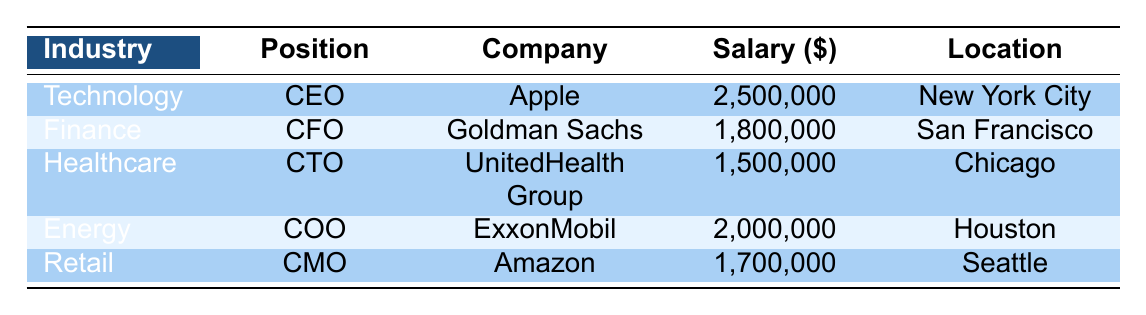What is the highest salary listed in the table? The table provides salaries for various positions across different companies. Scanning through the salary column, the highest figure is 2,500,000 associated with the position of CEO at Apple.
Answer: 2,500,000 Which company is offering the COO position in the table? The table outlines several positions along with their respective companies. By checking the position of COO, it is associated with ExxonMobil.
Answer: ExxonMobil What is the average salary across all positions listed in the table? To find the average salary, sum the salaries: 2,500,000 + 1,800,000 + 1,500,000 + 2,000,000 + 1,700,000 = 9,500,000. Then, divide this sum by the number of positions, which is 5. Thus, the average salary is 9,500,000 / 5 = 1,900,000.
Answer: 1,900,000 How many positions have a salary greater than 1,800,000? Reviewing the salary entries, we identify those above 1,800,000. These are 2,500,000 (CEO), 2,000,000 (COO), and 1,900,000 (CFO), which amounts to 3 positions.
Answer: 3 Is there a position listed in a healthcare company that has a salary below 1,600,000? The only healthcare company listed is UnitedHealth Group with the CTO position, which has a salary of 1,500,000. Since this figure is below 1,600,000, the answer is yes.
Answer: Yes What is the difference between the highest and lowest salaries in the table? The highest salary, as previously established, is 2,500,000, and the lowest salary is 1,500,000 for the CTO position. The difference is calculated as 2,500,000 - 1,500,000 = 1,000,000.
Answer: 1,000,000 Which industry has the lowest salary for its position? Referring to the salaries for each industry, we find the Finance position (CFO) offering the lowest salary of 1,800,000 when compared to other industries listed.
Answer: Finance Are there more than two companies listed for the energy sector? Examining the table, only one energy company, ExxonMobil, is mentioned for the COO position. Since there is only one, the assertion is false.
Answer: No What position offers the most stock options while also requiring the highest experience? The highest experience required is 16 years for the CEO position at Apple, which also offers 1,000,000 in stock options. Thus, the position is the CEO, providing the highest stock options in this context.
Answer: CEO In which location is the CFO position based? The CFO position is located in San Francisco according to the table, which directly lists the associated location for each position.
Answer: San Francisco Is it true that the COO position has more board seats than the CMO position? The COO position, belonging to ExxonMobil, has 2 board seats, whereas the CMO position at Amazon has only 1 board seat. Based on this comparison, the statement is true.
Answer: Yes 